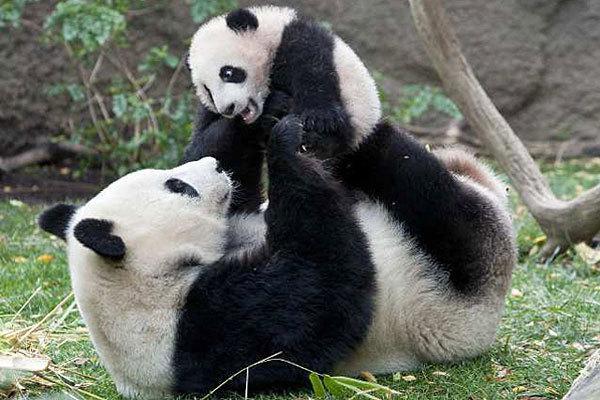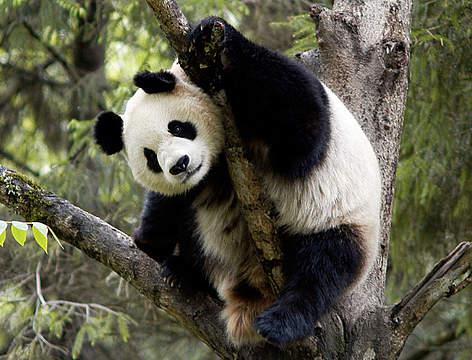The first image is the image on the left, the second image is the image on the right. Considering the images on both sides, is "The panda is sitting on top of a tree branch in the right image." valid? Answer yes or no. Yes. 